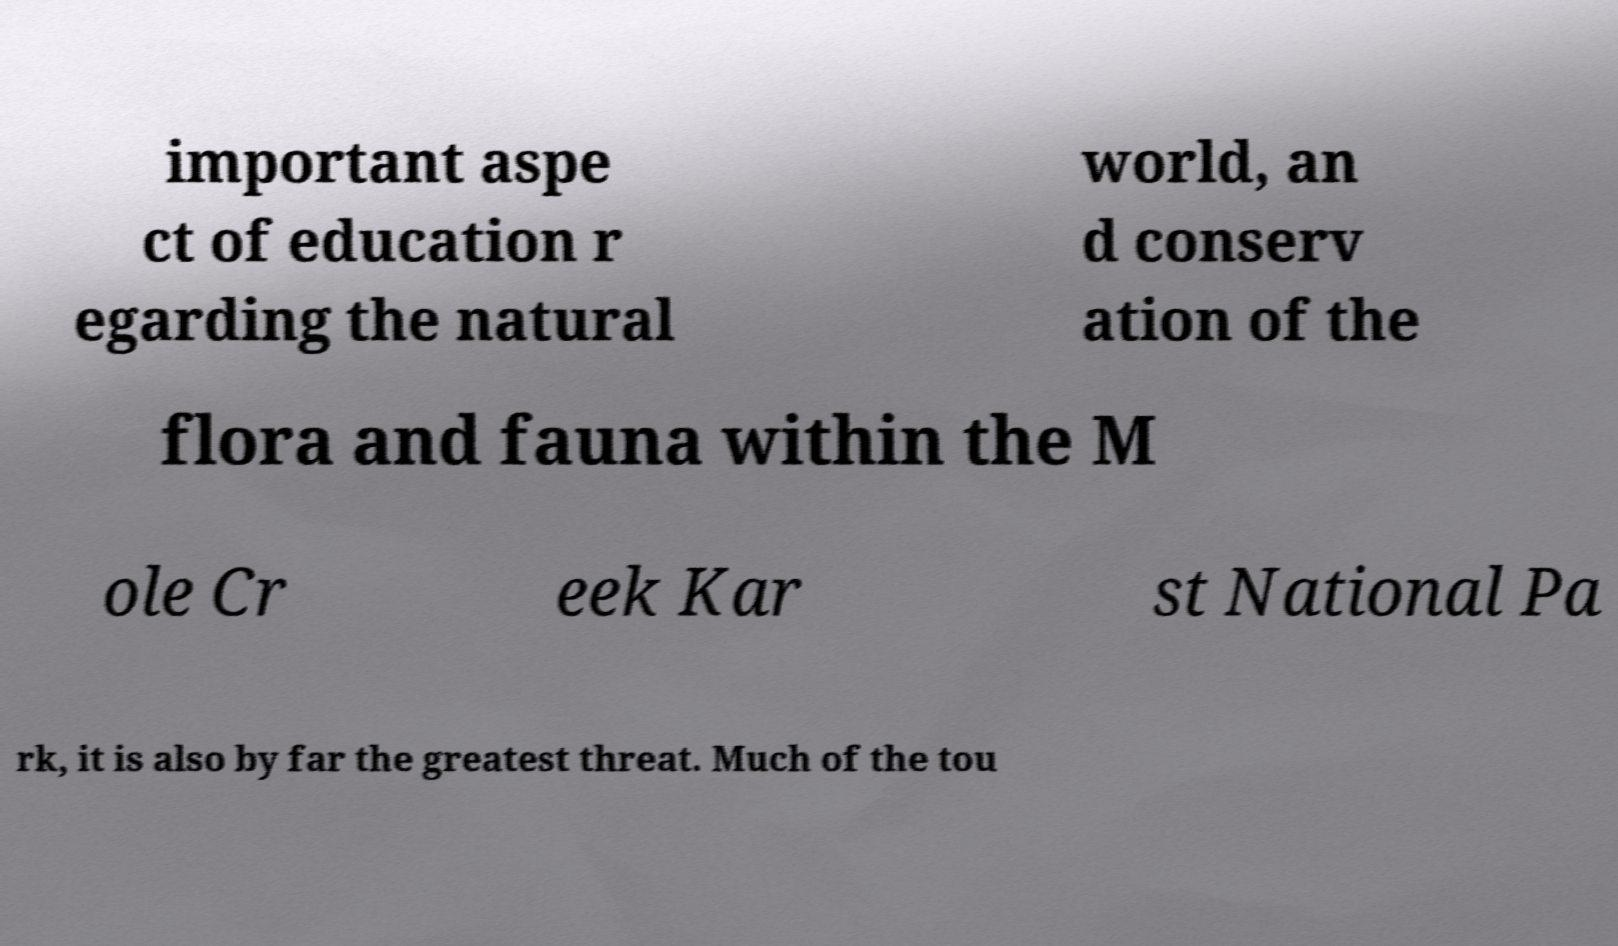Can you accurately transcribe the text from the provided image for me? important aspe ct of education r egarding the natural world, an d conserv ation of the flora and fauna within the M ole Cr eek Kar st National Pa rk, it is also by far the greatest threat. Much of the tou 